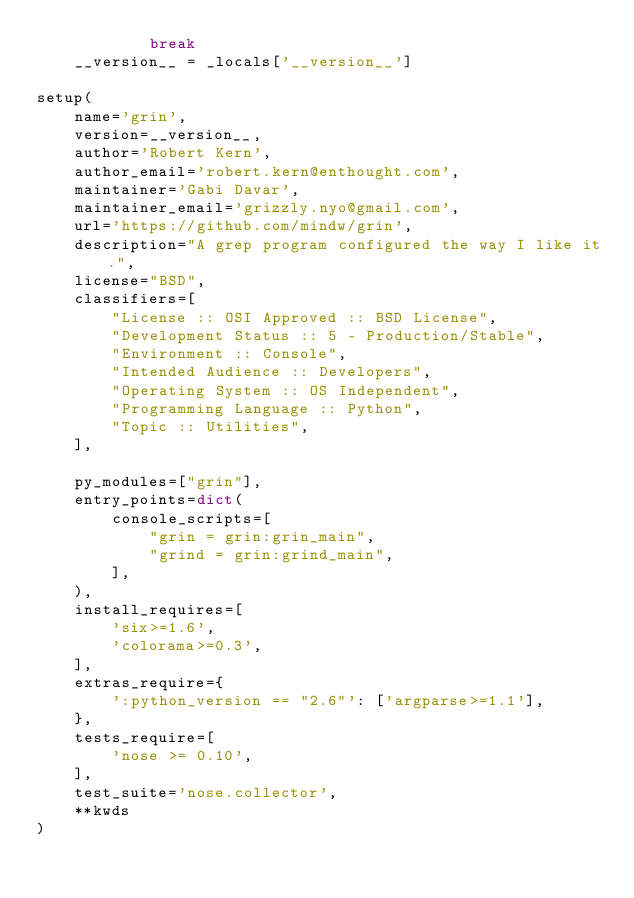Convert code to text. <code><loc_0><loc_0><loc_500><loc_500><_Python_>            break
    __version__ = _locals['__version__']

setup(
    name='grin',
    version=__version__,
    author='Robert Kern',
    author_email='robert.kern@enthought.com',
    maintainer='Gabi Davar',
    maintainer_email='grizzly.nyo@gmail.com',
    url='https://github.com/mindw/grin',
    description="A grep program configured the way I like it.",
    license="BSD",
    classifiers=[
        "License :: OSI Approved :: BSD License",
        "Development Status :: 5 - Production/Stable",
        "Environment :: Console",
        "Intended Audience :: Developers",
        "Operating System :: OS Independent",
        "Programming Language :: Python",
        "Topic :: Utilities",
    ],

    py_modules=["grin"],
    entry_points=dict(
        console_scripts=[
            "grin = grin:grin_main",
            "grind = grin:grind_main",
        ],
    ),
    install_requires=[
        'six>=1.6',
        'colorama>=0.3',
    ],
    extras_require={
        ':python_version == "2.6"': ['argparse>=1.1'],
    },
    tests_require=[
        'nose >= 0.10',
    ],
    test_suite='nose.collector',
    **kwds
)
</code> 